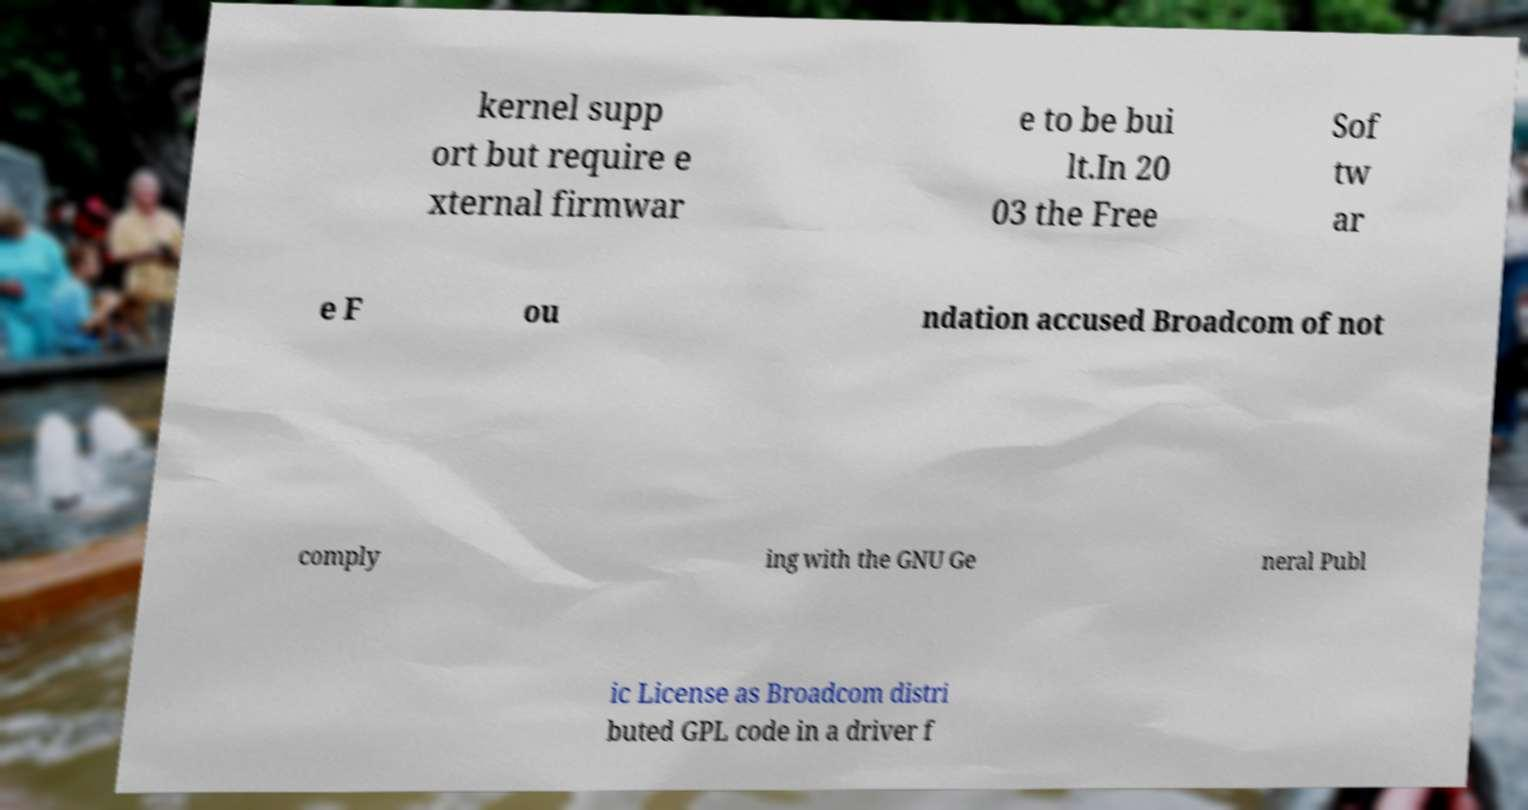There's text embedded in this image that I need extracted. Can you transcribe it verbatim? kernel supp ort but require e xternal firmwar e to be bui lt.In 20 03 the Free Sof tw ar e F ou ndation accused Broadcom of not comply ing with the GNU Ge neral Publ ic License as Broadcom distri buted GPL code in a driver f 